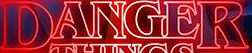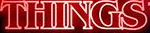Read the text from these images in sequence, separated by a semicolon. DANGER; THINGS 